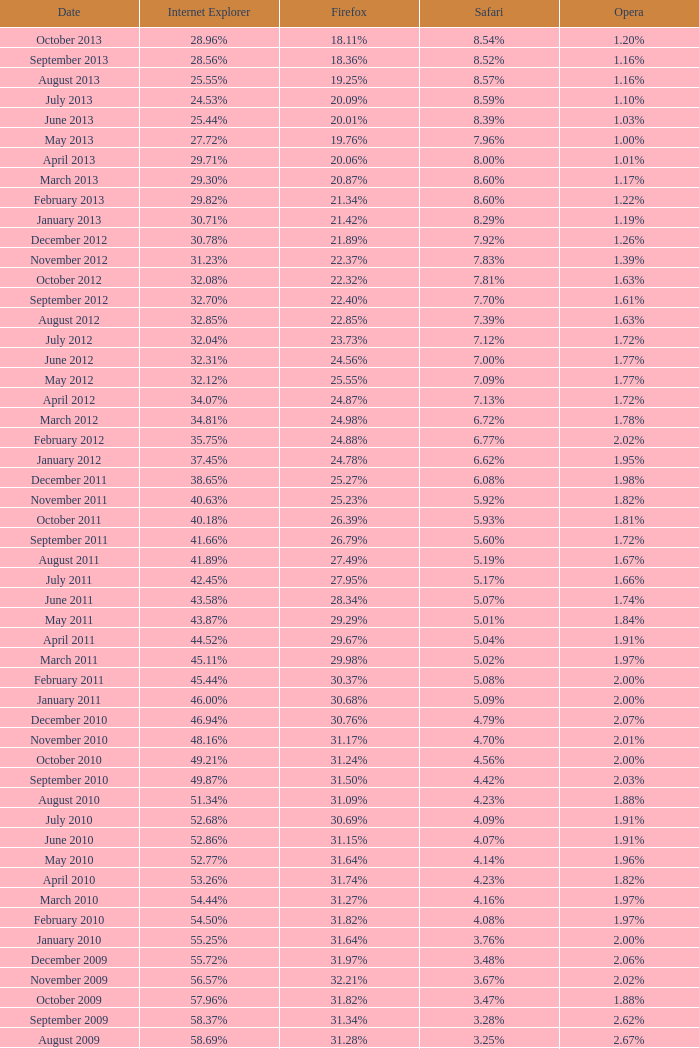Could you parse the entire table as a dict? {'header': ['Date', 'Internet Explorer', 'Firefox', 'Safari', 'Opera'], 'rows': [['October 2013', '28.96%', '18.11%', '8.54%', '1.20%'], ['September 2013', '28.56%', '18.36%', '8.52%', '1.16%'], ['August 2013', '25.55%', '19.25%', '8.57%', '1.16%'], ['July 2013', '24.53%', '20.09%', '8.59%', '1.10%'], ['June 2013', '25.44%', '20.01%', '8.39%', '1.03%'], ['May 2013', '27.72%', '19.76%', '7.96%', '1.00%'], ['April 2013', '29.71%', '20.06%', '8.00%', '1.01%'], ['March 2013', '29.30%', '20.87%', '8.60%', '1.17%'], ['February 2013', '29.82%', '21.34%', '8.60%', '1.22%'], ['January 2013', '30.71%', '21.42%', '8.29%', '1.19%'], ['December 2012', '30.78%', '21.89%', '7.92%', '1.26%'], ['November 2012', '31.23%', '22.37%', '7.83%', '1.39%'], ['October 2012', '32.08%', '22.32%', '7.81%', '1.63%'], ['September 2012', '32.70%', '22.40%', '7.70%', '1.61%'], ['August 2012', '32.85%', '22.85%', '7.39%', '1.63%'], ['July 2012', '32.04%', '23.73%', '7.12%', '1.72%'], ['June 2012', '32.31%', '24.56%', '7.00%', '1.77%'], ['May 2012', '32.12%', '25.55%', '7.09%', '1.77%'], ['April 2012', '34.07%', '24.87%', '7.13%', '1.72%'], ['March 2012', '34.81%', '24.98%', '6.72%', '1.78%'], ['February 2012', '35.75%', '24.88%', '6.77%', '2.02%'], ['January 2012', '37.45%', '24.78%', '6.62%', '1.95%'], ['December 2011', '38.65%', '25.27%', '6.08%', '1.98%'], ['November 2011', '40.63%', '25.23%', '5.92%', '1.82%'], ['October 2011', '40.18%', '26.39%', '5.93%', '1.81%'], ['September 2011', '41.66%', '26.79%', '5.60%', '1.72%'], ['August 2011', '41.89%', '27.49%', '5.19%', '1.67%'], ['July 2011', '42.45%', '27.95%', '5.17%', '1.66%'], ['June 2011', '43.58%', '28.34%', '5.07%', '1.74%'], ['May 2011', '43.87%', '29.29%', '5.01%', '1.84%'], ['April 2011', '44.52%', '29.67%', '5.04%', '1.91%'], ['March 2011', '45.11%', '29.98%', '5.02%', '1.97%'], ['February 2011', '45.44%', '30.37%', '5.08%', '2.00%'], ['January 2011', '46.00%', '30.68%', '5.09%', '2.00%'], ['December 2010', '46.94%', '30.76%', '4.79%', '2.07%'], ['November 2010', '48.16%', '31.17%', '4.70%', '2.01%'], ['October 2010', '49.21%', '31.24%', '4.56%', '2.00%'], ['September 2010', '49.87%', '31.50%', '4.42%', '2.03%'], ['August 2010', '51.34%', '31.09%', '4.23%', '1.88%'], ['July 2010', '52.68%', '30.69%', '4.09%', '1.91%'], ['June 2010', '52.86%', '31.15%', '4.07%', '1.91%'], ['May 2010', '52.77%', '31.64%', '4.14%', '1.96%'], ['April 2010', '53.26%', '31.74%', '4.23%', '1.82%'], ['March 2010', '54.44%', '31.27%', '4.16%', '1.97%'], ['February 2010', '54.50%', '31.82%', '4.08%', '1.97%'], ['January 2010', '55.25%', '31.64%', '3.76%', '2.00%'], ['December 2009', '55.72%', '31.97%', '3.48%', '2.06%'], ['November 2009', '56.57%', '32.21%', '3.67%', '2.02%'], ['October 2009', '57.96%', '31.82%', '3.47%', '1.88%'], ['September 2009', '58.37%', '31.34%', '3.28%', '2.62%'], ['August 2009', '58.69%', '31.28%', '3.25%', '2.67%'], ['July 2009', '60.11%', '30.50%', '3.02%', '2.64%'], ['June 2009', '59.49%', '30.26%', '2.91%', '3.46%'], ['May 2009', '62.09%', '28.75%', '2.65%', '3.23%'], ['April 2009', '61.88%', '29.67%', '2.75%', '2.96%'], ['March 2009', '62.52%', '29.40%', '2.73%', '2.94%'], ['February 2009', '64.43%', '27.85%', '2.59%', '2.95%'], ['January 2009', '65.41%', '27.03%', '2.57%', '2.92%'], ['December 2008', '67.84%', '25.23%', '2.41%', '2.83%'], ['November 2008', '68.14%', '25.27%', '2.49%', '3.01%'], ['October 2008', '67.68%', '25.54%', '2.91%', '2.69%'], ['September2008', '67.16%', '25.77%', '3.00%', '2.86%'], ['August 2008', '68.91%', '26.08%', '2.99%', '1.83%'], ['July 2008', '68.57%', '26.14%', '3.30%', '1.78%']]} During the time when firefox had a 27.85% usage rate, what proportion of browsers were utilizing internet explorer? 64.43%. 